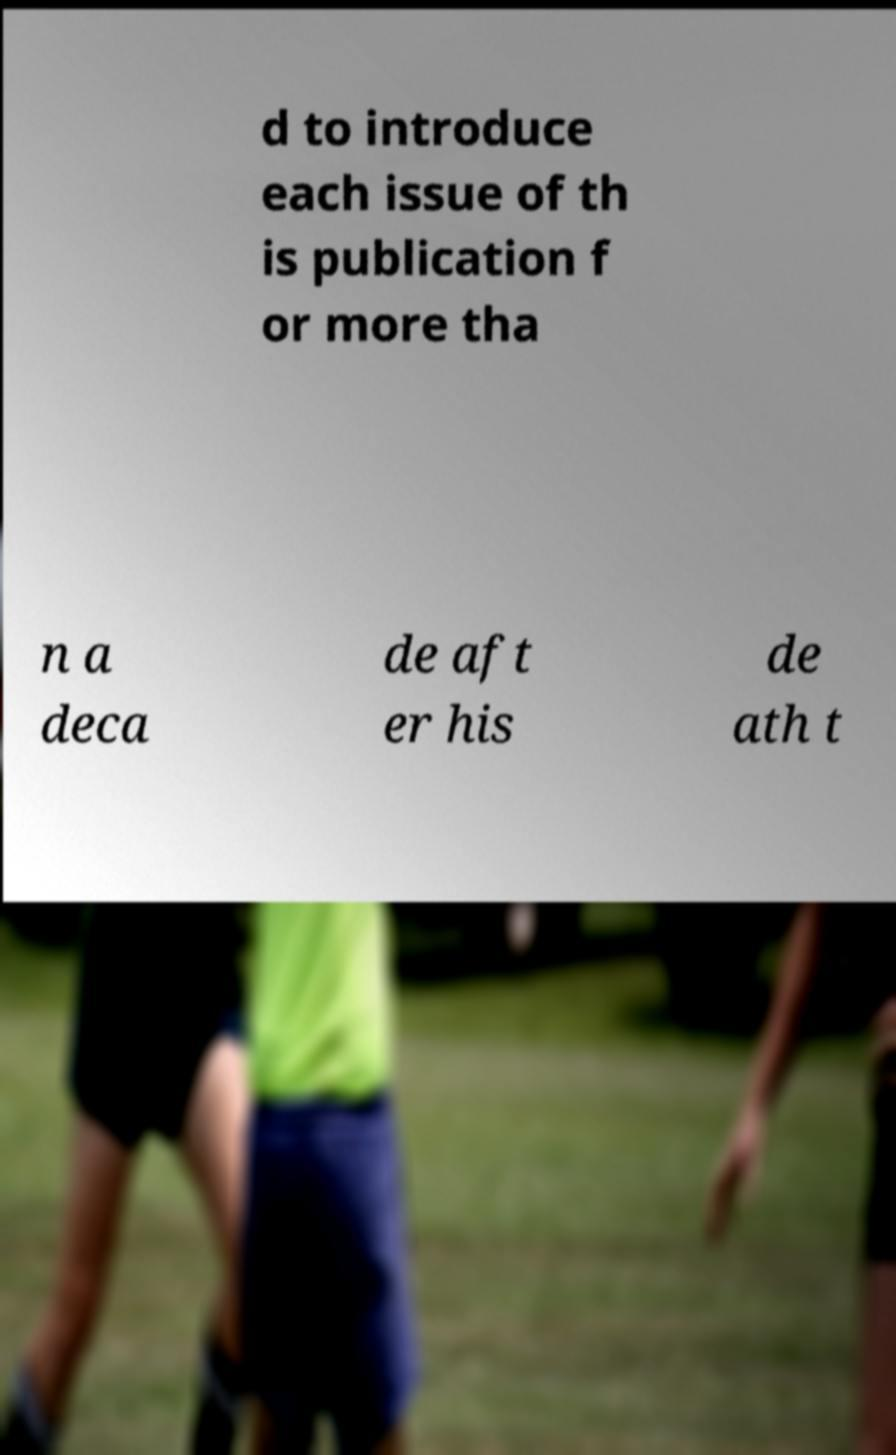I need the written content from this picture converted into text. Can you do that? d to introduce each issue of th is publication f or more tha n a deca de aft er his de ath t 